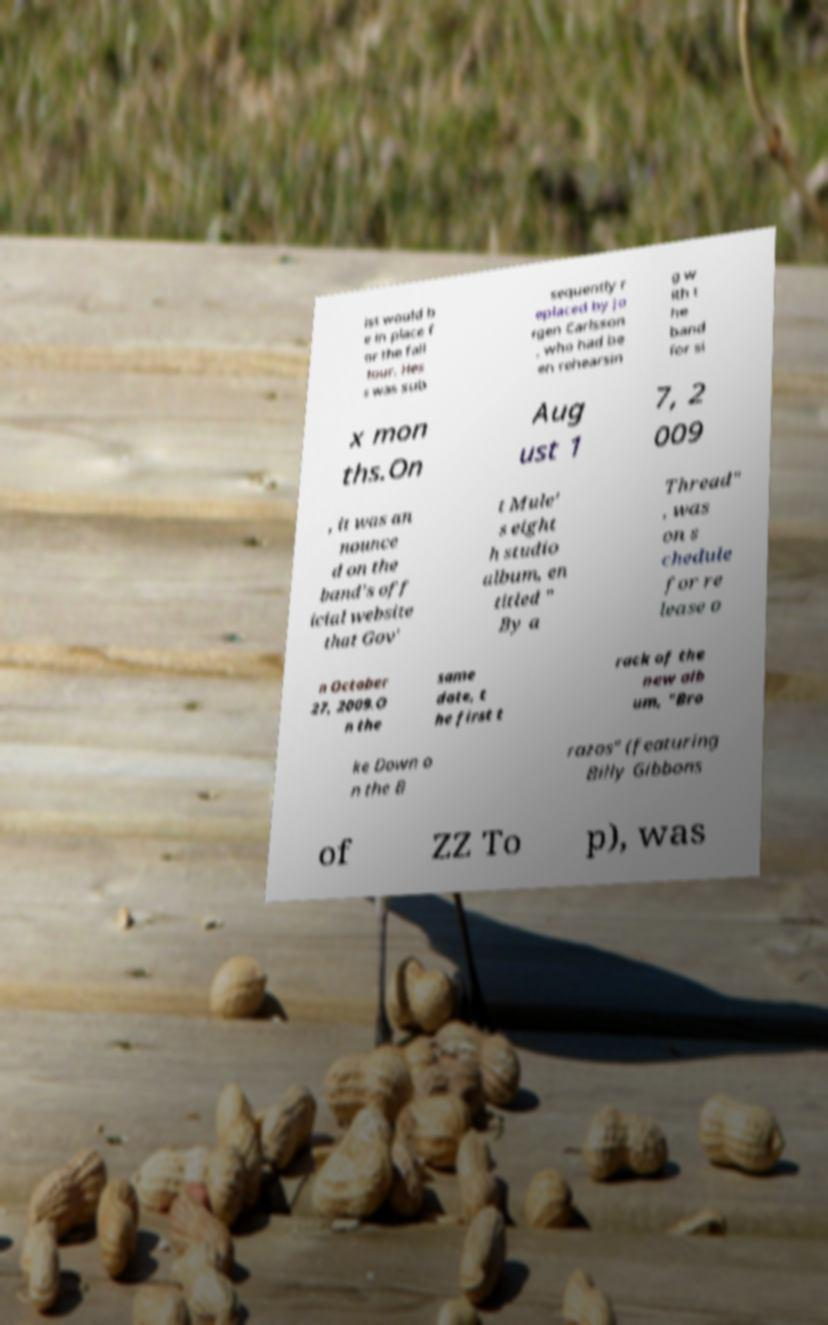There's text embedded in this image that I need extracted. Can you transcribe it verbatim? ist would b e in place f or the fall tour. Hes s was sub sequently r eplaced by Jo rgen Carlsson , who had be en rehearsin g w ith t he band for si x mon ths.On Aug ust 1 7, 2 009 , it was an nounce d on the band's off icial website that Gov' t Mule' s eight h studio album, en titled " By a Thread" , was on s chedule for re lease o n October 27, 2009.O n the same date, t he first t rack of the new alb um, "Bro ke Down o n the B razos" (featuring Billy Gibbons of ZZ To p), was 